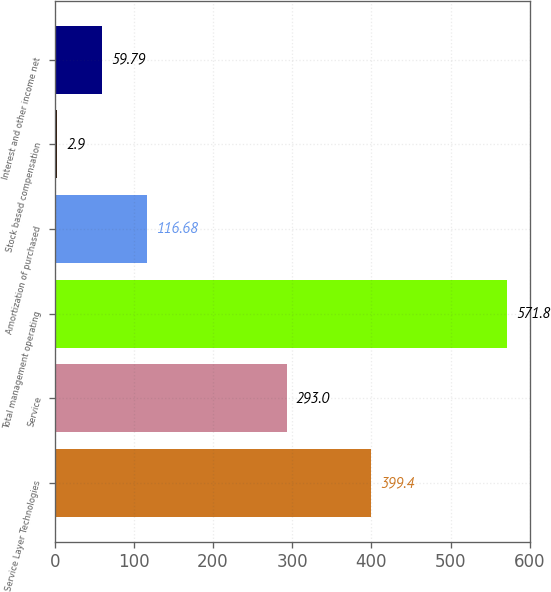Convert chart to OTSL. <chart><loc_0><loc_0><loc_500><loc_500><bar_chart><fcel>Service Layer Technologies<fcel>Service<fcel>Total management operating<fcel>Amortization of purchased<fcel>Stock based compensation<fcel>Interest and other income net<nl><fcel>399.4<fcel>293<fcel>571.8<fcel>116.68<fcel>2.9<fcel>59.79<nl></chart> 